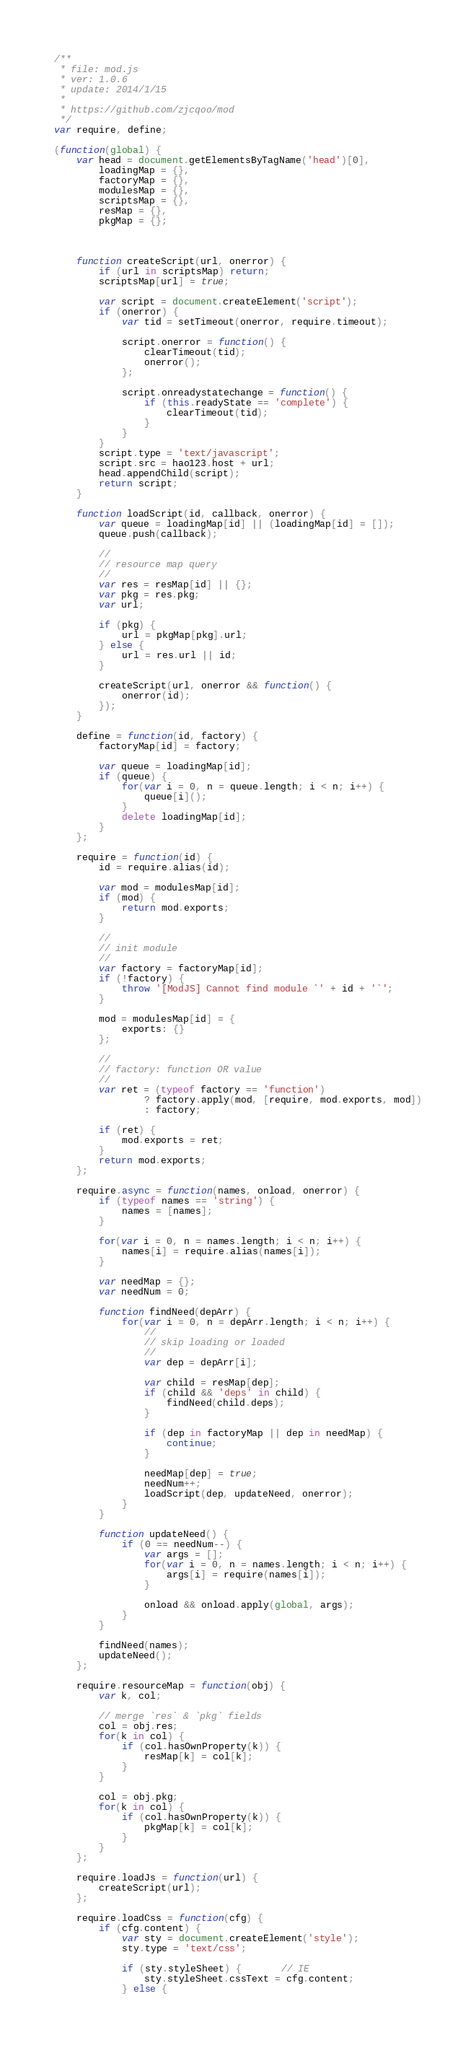Convert code to text. <code><loc_0><loc_0><loc_500><loc_500><_JavaScript_>/**
 * file: mod.js
 * ver: 1.0.6
 * update: 2014/1/15
 *
 * https://github.com/zjcqoo/mod
 */
var require, define;

(function(global) {
    var head = document.getElementsByTagName('head')[0],
        loadingMap = {},
        factoryMap = {},
        modulesMap = {},
        scriptsMap = {},
        resMap = {},
        pkgMap = {};



    function createScript(url, onerror) {
        if (url in scriptsMap) return;
        scriptsMap[url] = true;

        var script = document.createElement('script');
        if (onerror) {
            var tid = setTimeout(onerror, require.timeout);

            script.onerror = function() {
                clearTimeout(tid);
                onerror();
            };

            script.onreadystatechange = function() {
                if (this.readyState == 'complete') {
                    clearTimeout(tid);
                }
            }
        }
        script.type = 'text/javascript';
        script.src = hao123.host + url;
        head.appendChild(script);
        return script;
    }

    function loadScript(id, callback, onerror) {
        var queue = loadingMap[id] || (loadingMap[id] = []);
        queue.push(callback);

        //
        // resource map query
        //
        var res = resMap[id] || {};
        var pkg = res.pkg;
        var url;

        if (pkg) {
            url = pkgMap[pkg].url;
        } else {
            url = res.url || id;
        }

        createScript(url, onerror && function() {
            onerror(id);
        });
    }

    define = function(id, factory) {
        factoryMap[id] = factory;

        var queue = loadingMap[id];
        if (queue) {
            for(var i = 0, n = queue.length; i < n; i++) {
                queue[i]();
            }
            delete loadingMap[id];
        }
    };

    require = function(id) {
        id = require.alias(id);

        var mod = modulesMap[id];
        if (mod) {
            return mod.exports;
        }

        //
        // init module
        //
        var factory = factoryMap[id];
        if (!factory) {
            throw '[ModJS] Cannot find module `' + id + '`';
        }

        mod = modulesMap[id] = {
            exports: {}
        };

        //
        // factory: function OR value
        //
        var ret = (typeof factory == 'function')
                ? factory.apply(mod, [require, mod.exports, mod])
                : factory;

        if (ret) {
            mod.exports = ret;
        }
        return mod.exports;
    };

    require.async = function(names, onload, onerror) {
        if (typeof names == 'string') {
            names = [names];
        }
        
        for(var i = 0, n = names.length; i < n; i++) {
            names[i] = require.alias(names[i]);
        }

        var needMap = {};
        var needNum = 0;

        function findNeed(depArr) {
            for(var i = 0, n = depArr.length; i < n; i++) {
                //
                // skip loading or loaded
                //
                var dep = depArr[i];

                var child = resMap[dep];
                if (child && 'deps' in child) {
                    findNeed(child.deps);
                }
                
                if (dep in factoryMap || dep in needMap) {
                    continue;
                }

                needMap[dep] = true;
                needNum++;
                loadScript(dep, updateNeed, onerror);
            }
        }

        function updateNeed() {
            if (0 == needNum--) {
                var args = [];
                for(var i = 0, n = names.length; i < n; i++) {
                    args[i] = require(names[i]);
                }

                onload && onload.apply(global, args);
            }
        }
        
        findNeed(names);
        updateNeed();
    };

    require.resourceMap = function(obj) {
        var k, col;

        // merge `res` & `pkg` fields
        col = obj.res;
        for(k in col) {
            if (col.hasOwnProperty(k)) {
                resMap[k] = col[k];
            }
        }

        col = obj.pkg;
        for(k in col) {
            if (col.hasOwnProperty(k)) {
                pkgMap[k] = col[k];
            }
        }
    };

    require.loadJs = function(url) {
        createScript(url);
    };

    require.loadCss = function(cfg) {
        if (cfg.content) {
            var sty = document.createElement('style');
            sty.type = 'text/css';
            
            if (sty.styleSheet) {       // IE
                sty.styleSheet.cssText = cfg.content;
            } else {</code> 